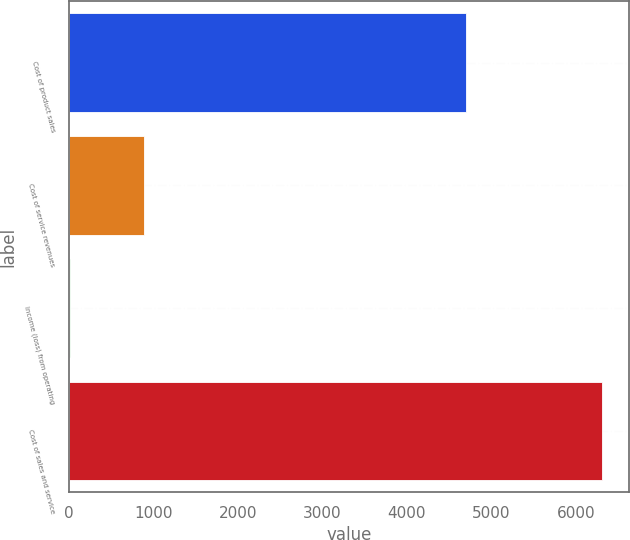Convert chart. <chart><loc_0><loc_0><loc_500><loc_500><bar_chart><fcel>Cost of product sales<fcel>Cost of service revenues<fcel>Income (loss) from operating<fcel>Cost of sales and service<nl><fcel>4695<fcel>888<fcel>14<fcel>6308<nl></chart> 